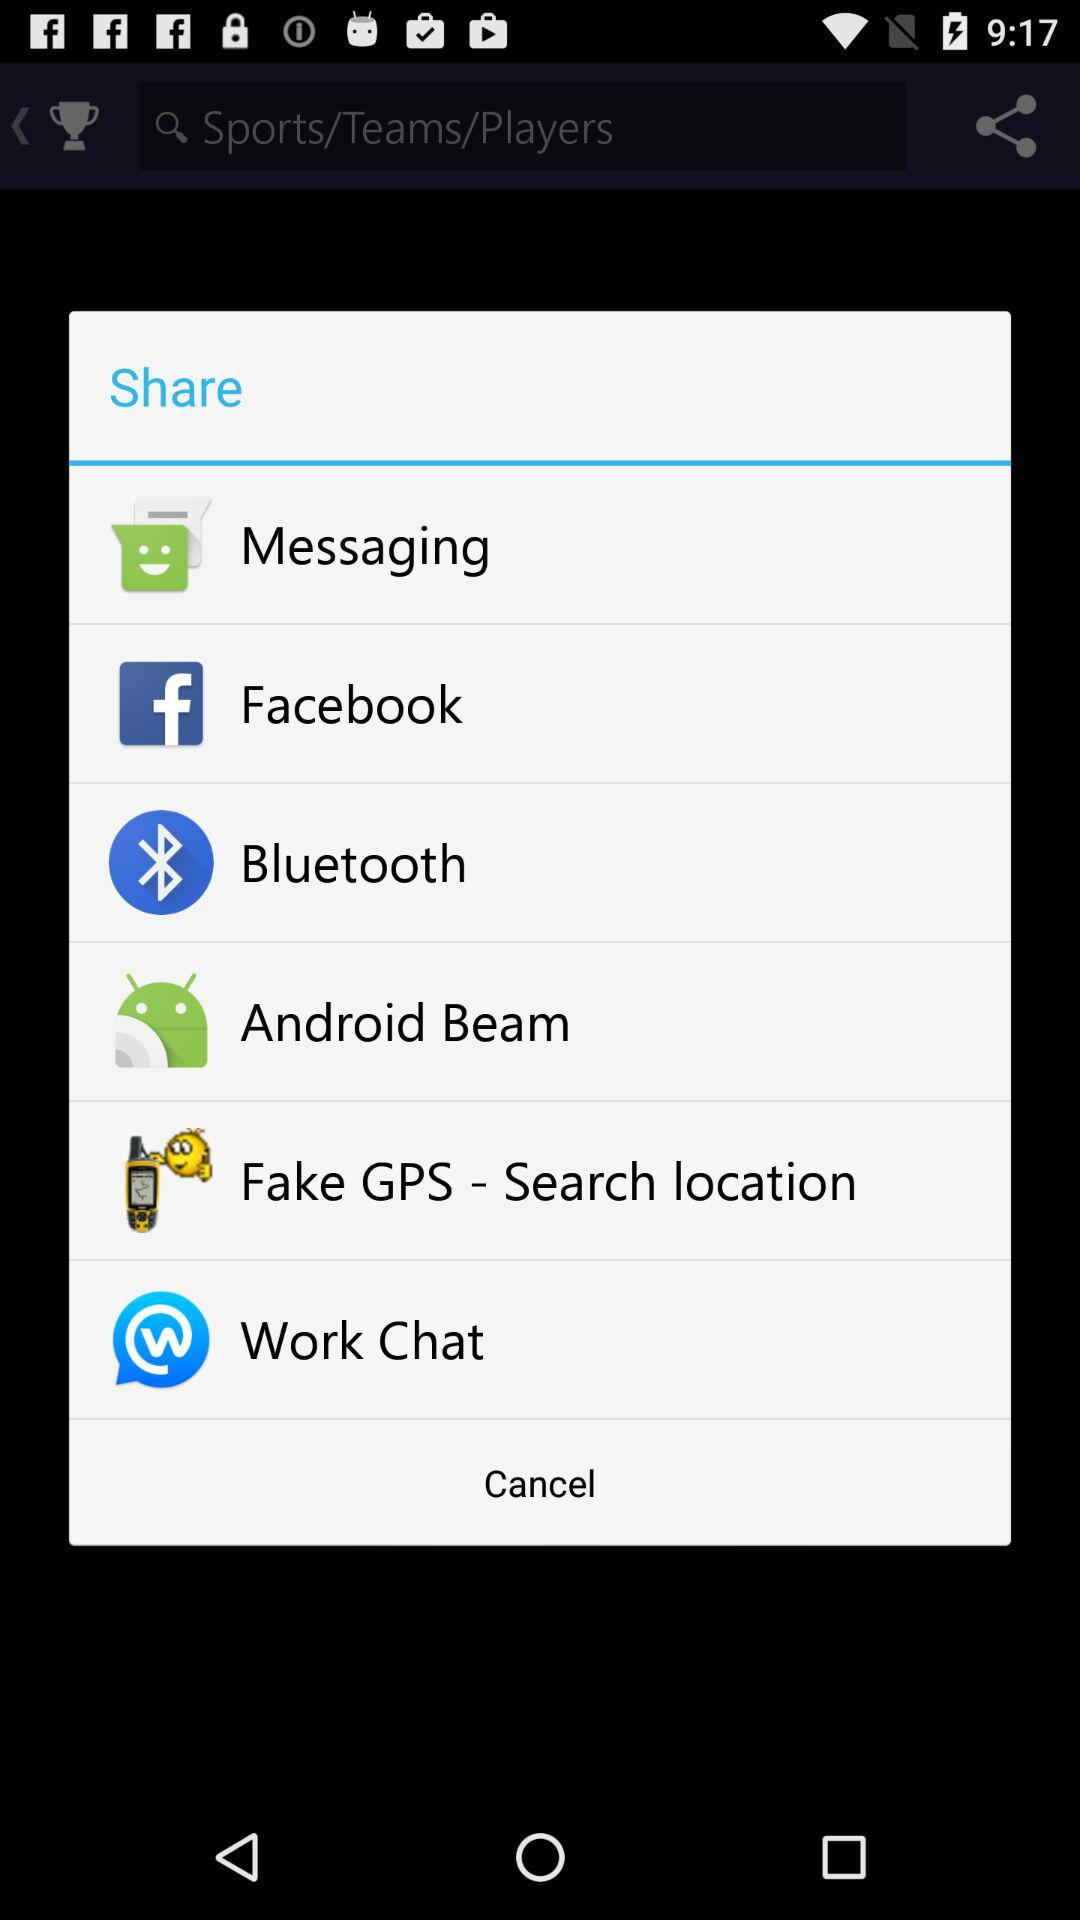How many items are there in the share menu?
Answer the question using a single word or phrase. 6 